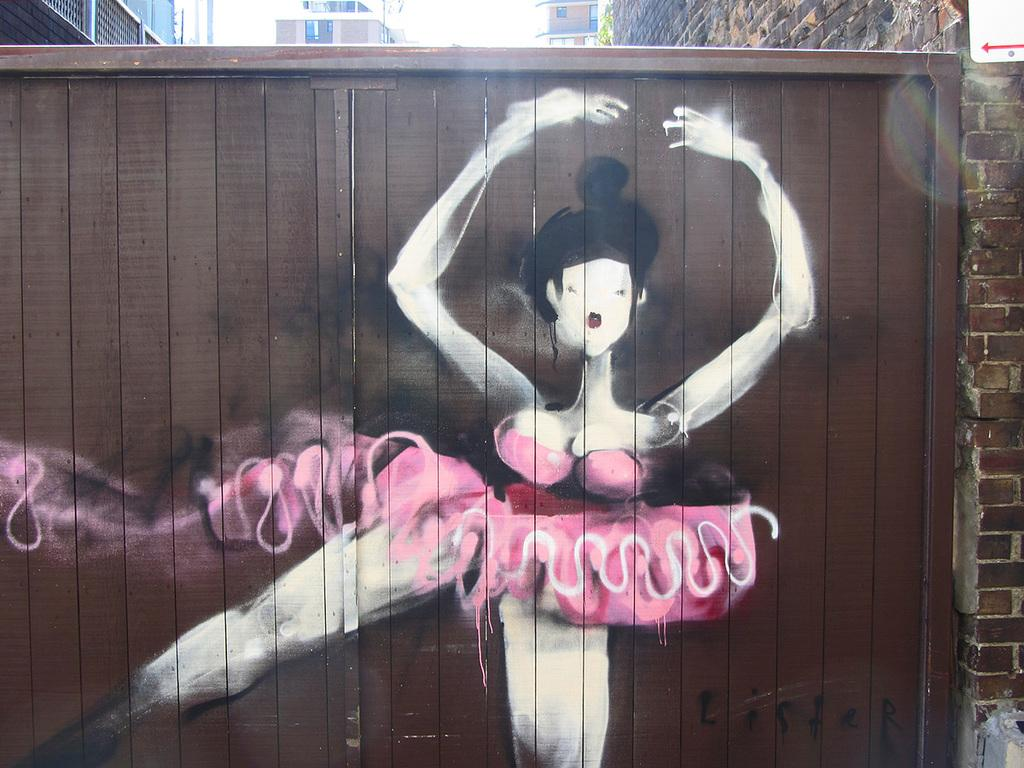What type of artwork can be seen on a surface in the image? There is graffiti painting on a wooden wall in the image. What other type of wall is present in the image? There is a brick wall on the right side of the image. What can be seen in the background of the image? Buildings are visible at the top of the image. What type of balls are being used in the battle depicted in the image? There is no battle or balls present in the image; it features graffiti on a wooden wall and a brick wall. What type of property is being disputed in the image? There is no property dispute or property present in the image. 